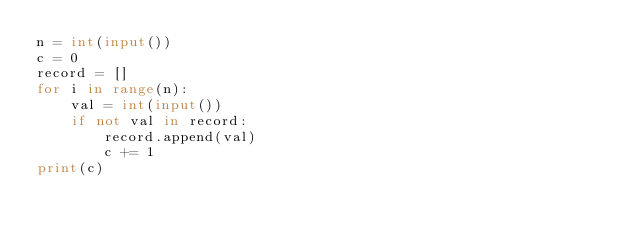<code> <loc_0><loc_0><loc_500><loc_500><_Python_>n = int(input())
c = 0
record = []
for i in range(n):
    val = int(input())
    if not val in record:
        record.append(val)
        c += 1
print(c)</code> 